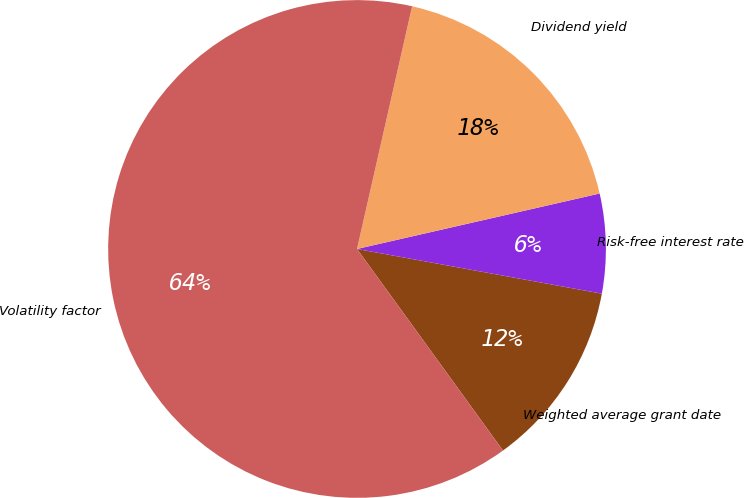<chart> <loc_0><loc_0><loc_500><loc_500><pie_chart><fcel>Weighted average grant date<fcel>Risk-free interest rate<fcel>Dividend yield<fcel>Volatility factor<nl><fcel>12.15%<fcel>6.45%<fcel>17.87%<fcel>63.53%<nl></chart> 